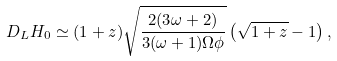Convert formula to latex. <formula><loc_0><loc_0><loc_500><loc_500>D _ { L } H _ { 0 } \simeq ( 1 + z ) \sqrt { \frac { 2 ( 3 \omega + 2 ) } { 3 ( \omega + 1 ) \Omega { \phi } } } \left ( \sqrt { 1 + z } - 1 \right ) ,</formula> 